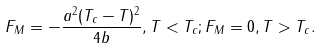<formula> <loc_0><loc_0><loc_500><loc_500>F _ { M } = - \frac { a ^ { 2 } ( T _ { c } - T ) ^ { 2 } } { 4 b } , T < T _ { c } ; F _ { M } = 0 , T > T _ { c } .</formula> 